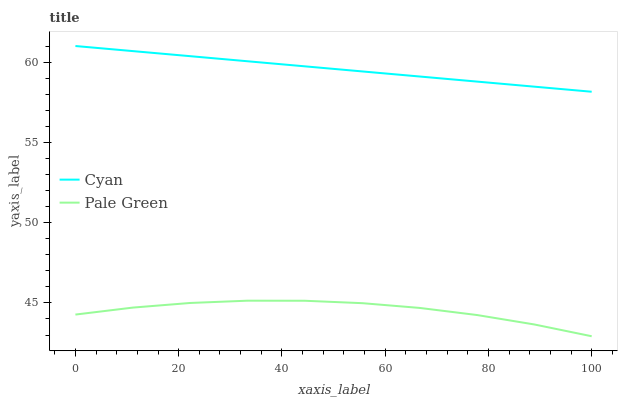Does Pale Green have the minimum area under the curve?
Answer yes or no. Yes. Does Cyan have the maximum area under the curve?
Answer yes or no. Yes. Does Pale Green have the maximum area under the curve?
Answer yes or no. No. Is Cyan the smoothest?
Answer yes or no. Yes. Is Pale Green the roughest?
Answer yes or no. Yes. Is Pale Green the smoothest?
Answer yes or no. No. Does Pale Green have the lowest value?
Answer yes or no. Yes. Does Cyan have the highest value?
Answer yes or no. Yes. Does Pale Green have the highest value?
Answer yes or no. No. Is Pale Green less than Cyan?
Answer yes or no. Yes. Is Cyan greater than Pale Green?
Answer yes or no. Yes. Does Pale Green intersect Cyan?
Answer yes or no. No. 